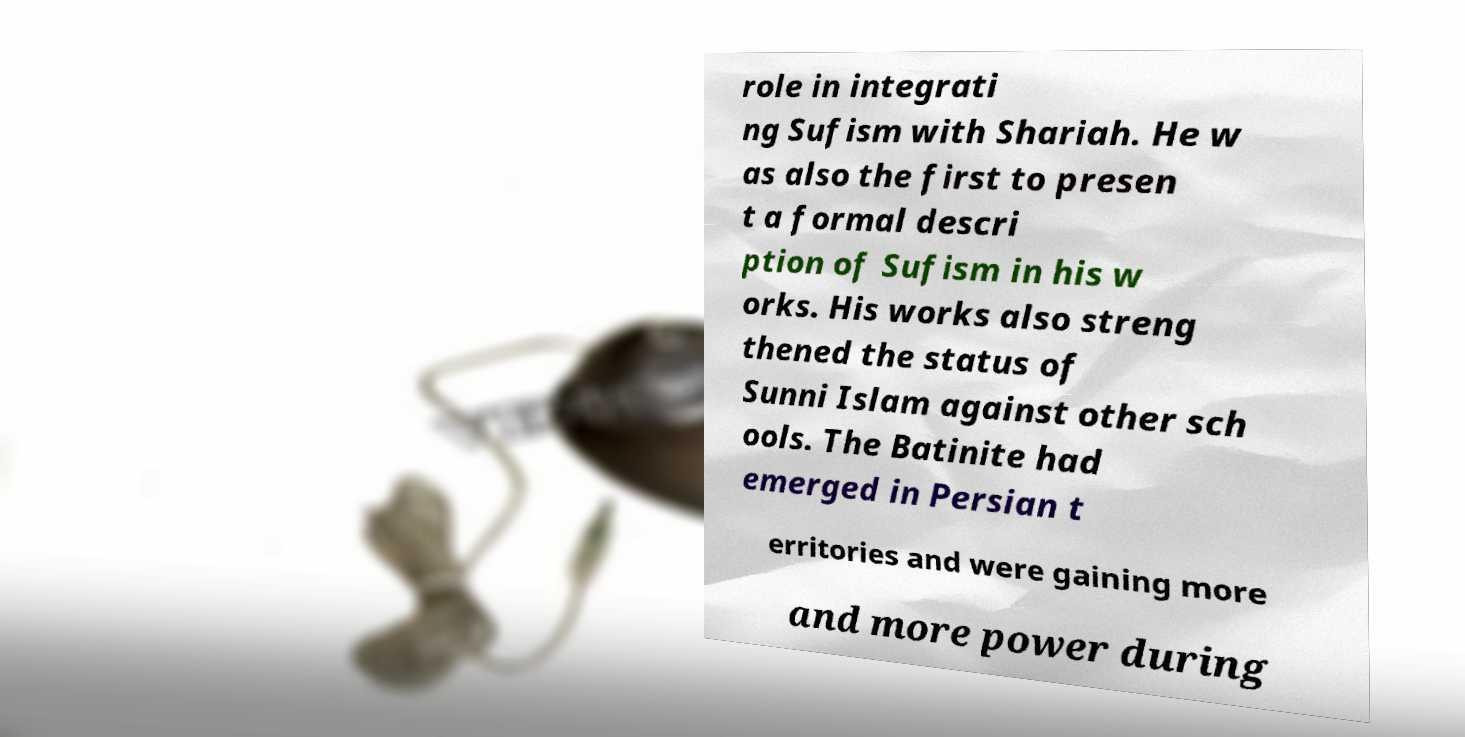What messages or text are displayed in this image? I need them in a readable, typed format. role in integrati ng Sufism with Shariah. He w as also the first to presen t a formal descri ption of Sufism in his w orks. His works also streng thened the status of Sunni Islam against other sch ools. The Batinite had emerged in Persian t erritories and were gaining more and more power during 